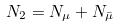<formula> <loc_0><loc_0><loc_500><loc_500>N _ { 2 } = N _ { \mu } + N _ { \bar { \mu } }</formula> 